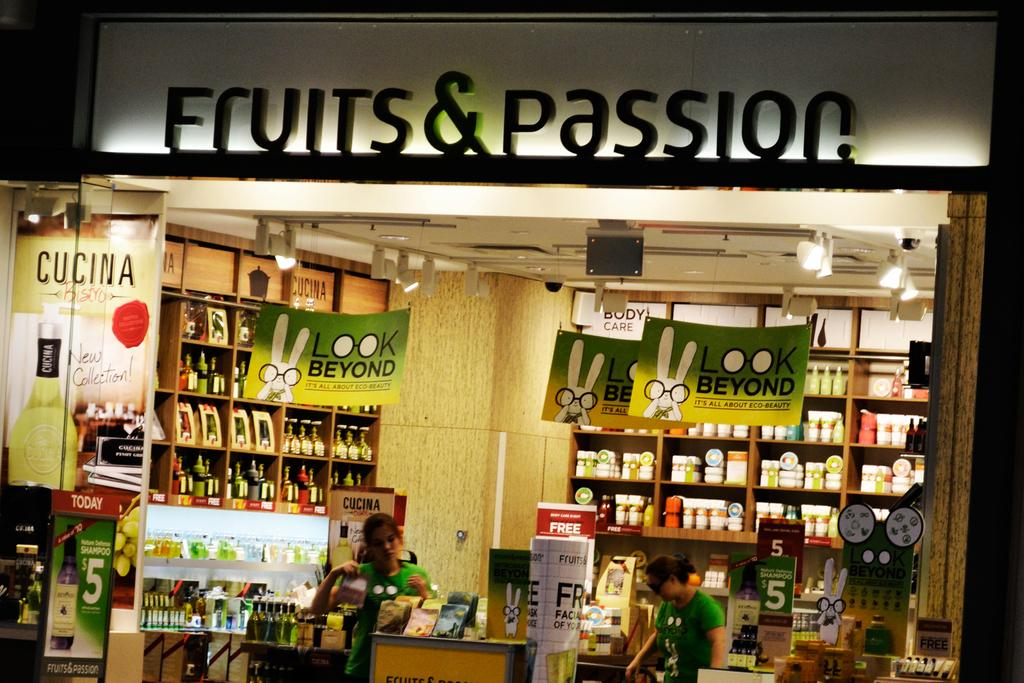<image>
Give a short and clear explanation of the subsequent image. Two women standing inside a very well organized store called Fruits & Passion. 